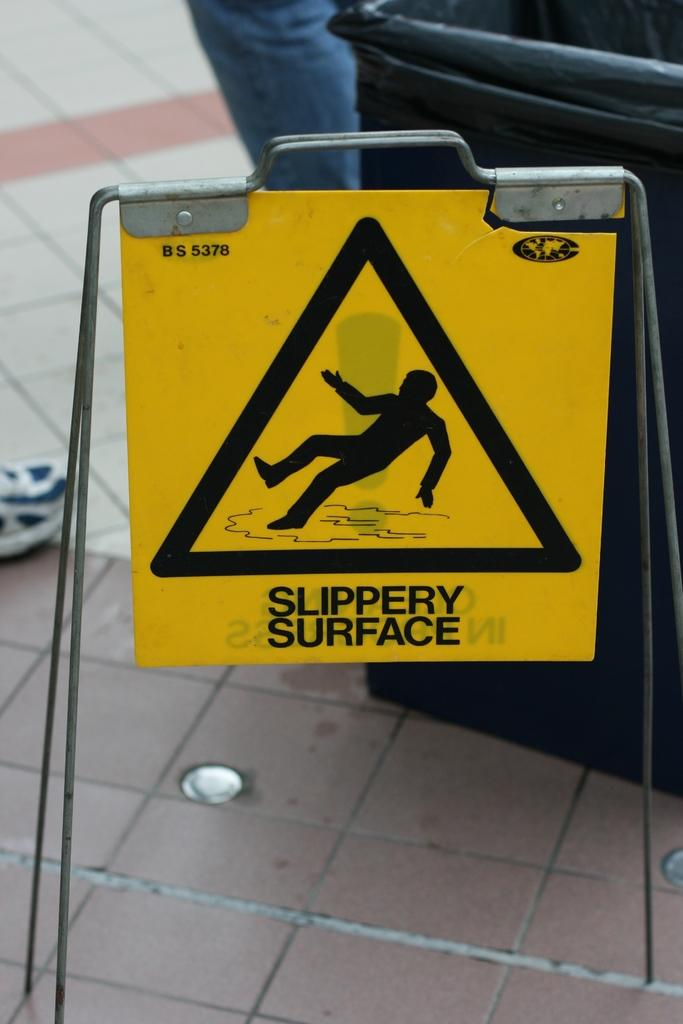<image>
Offer a succinct explanation of the picture presented. A yellow and black sign advising people that there is a slippery surface. 